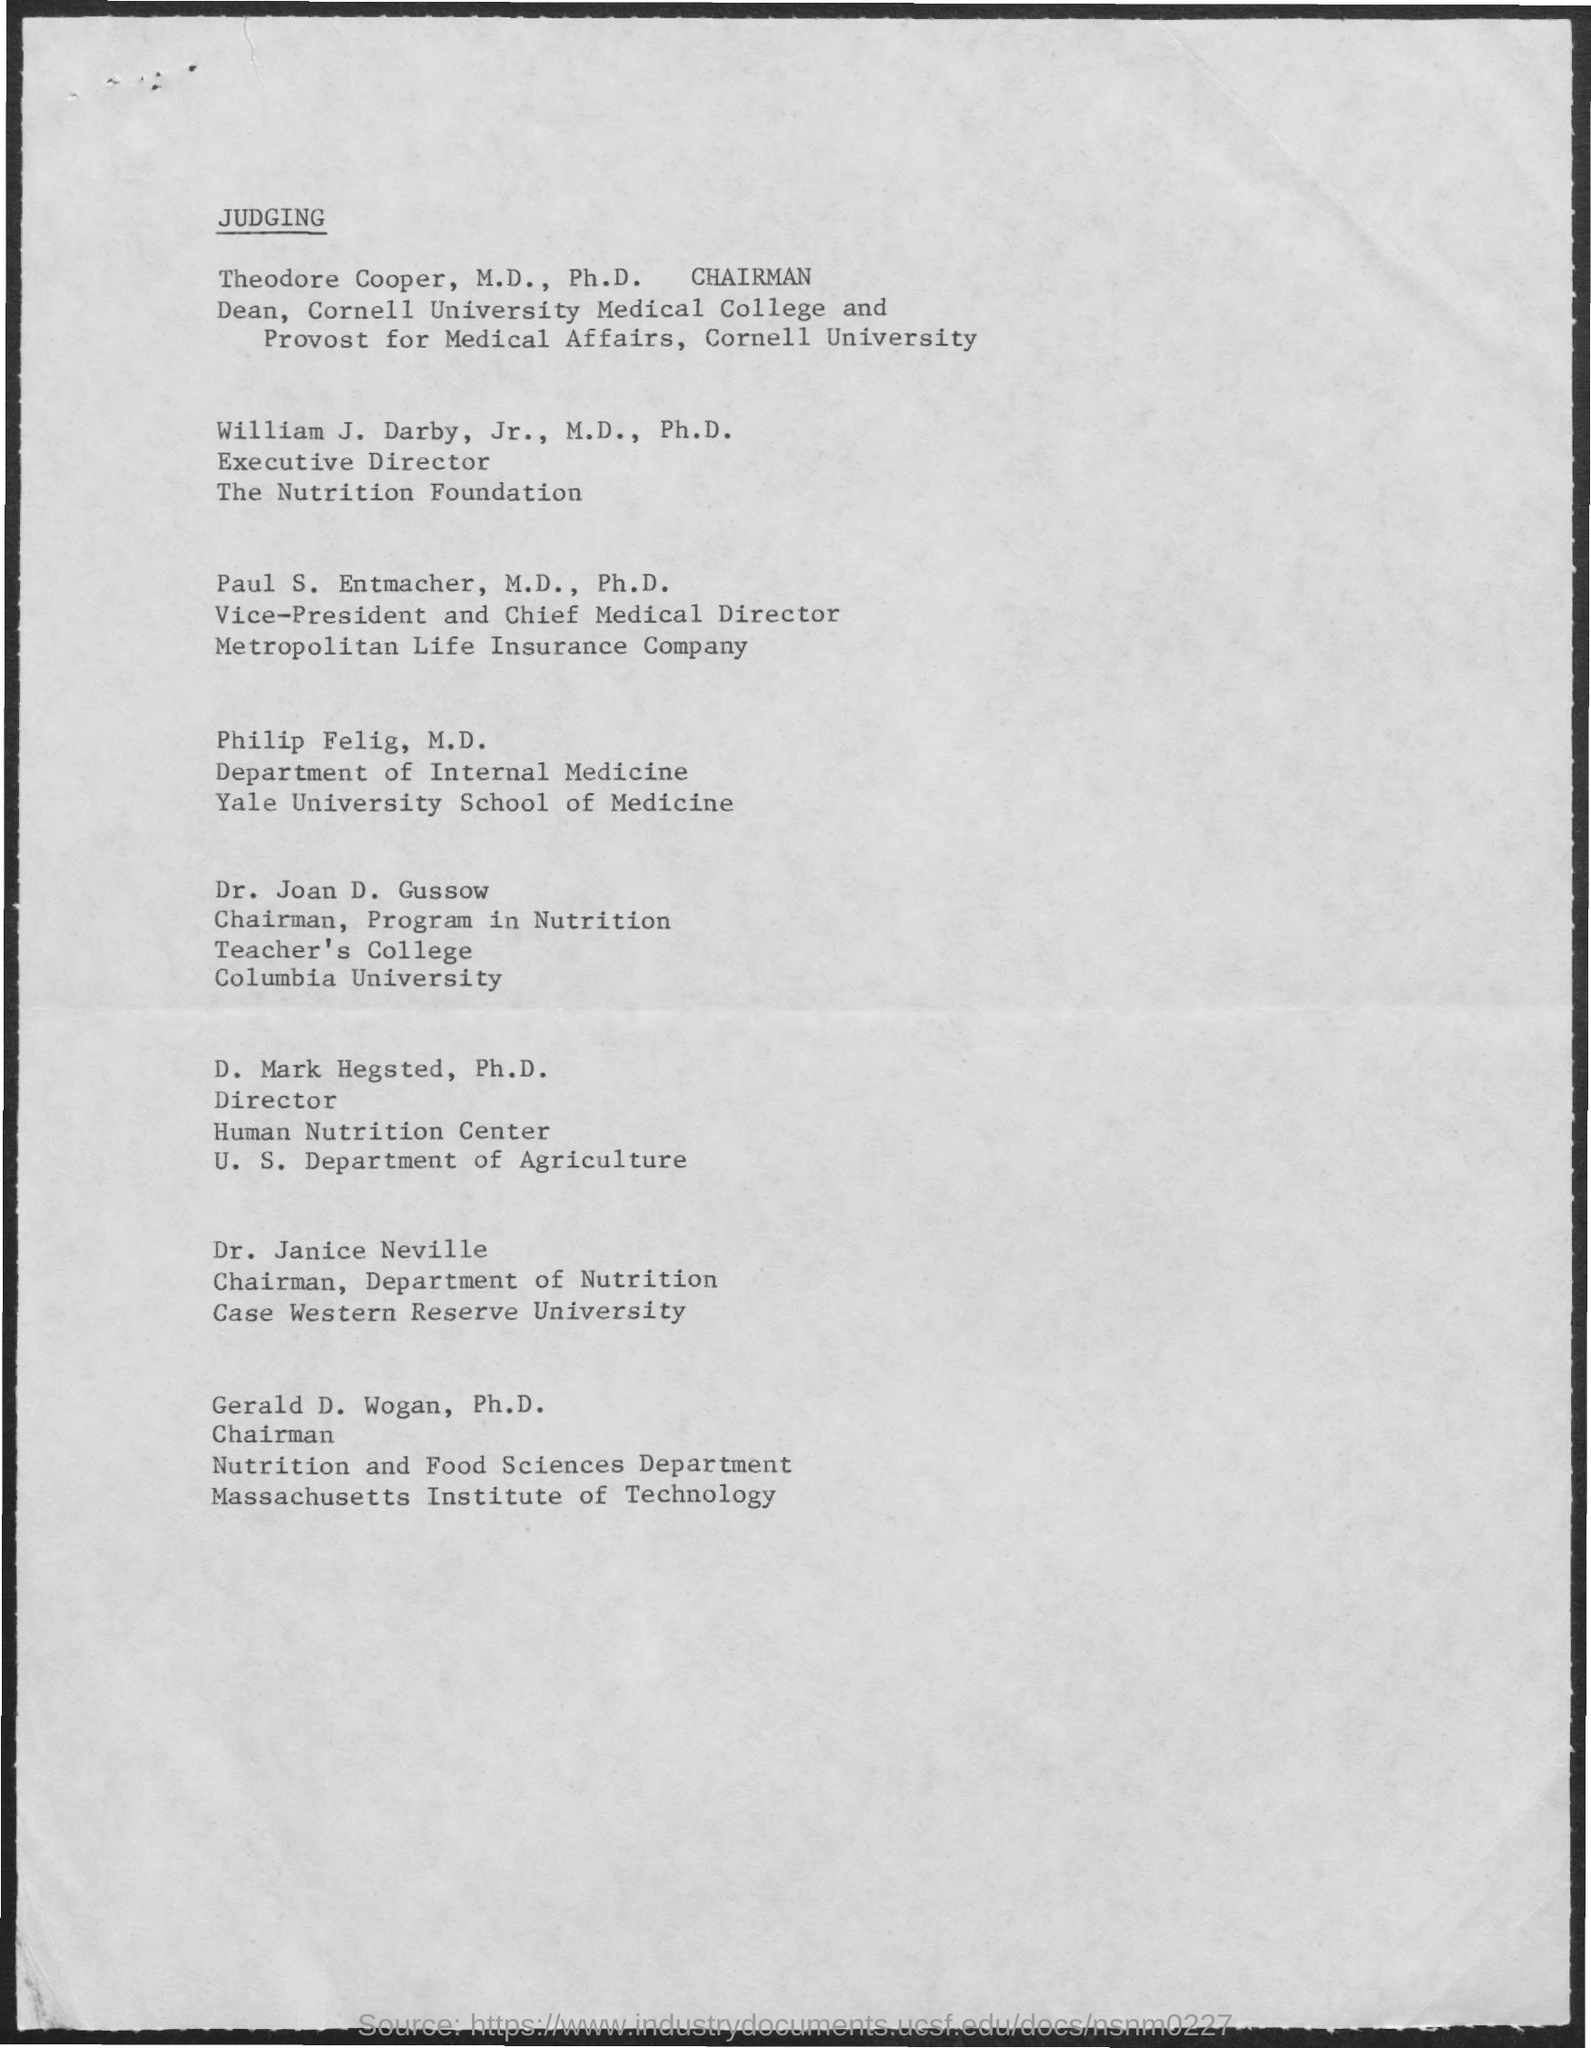Identify some key points in this picture. What is the title of the document that we are currently judging? The Nutrition Foundation's Executive Director is William J. Darby. The Dean of Cornell University Medical College is Theodore Copper, M.D., Ph.D. The Chairman of the Department of Nutrition is Dr. Janice Neville. Gerald D. Wogan, Ph.D., is the Chairman of the Nutrition and Food Sciences Department. 